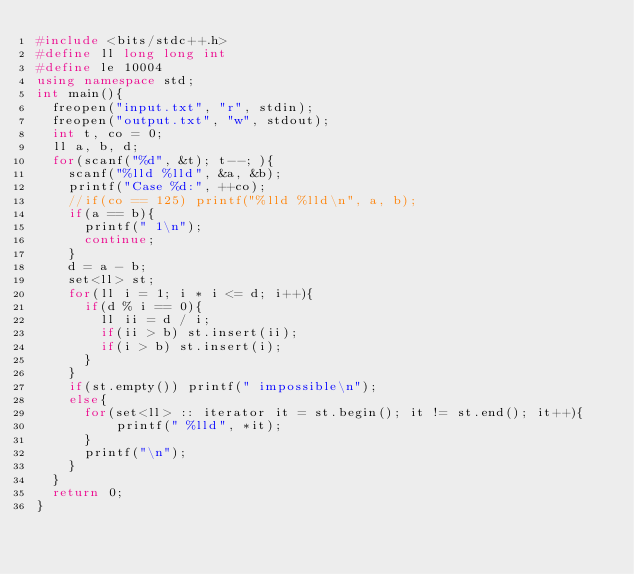Convert code to text. <code><loc_0><loc_0><loc_500><loc_500><_C++_>#include <bits/stdc++.h>
#define ll long long int
#define le 10004
using namespace std;
int main(){
  freopen("input.txt", "r", stdin);
  freopen("output.txt", "w", stdout);
  int t, co = 0;
  ll a, b, d;
  for(scanf("%d", &t); t--; ){
    scanf("%lld %lld", &a, &b);
    printf("Case %d:", ++co);
    //if(co == 125) printf("%lld %lld\n", a, b);
    if(a == b){
      printf(" 1\n");
      continue;
    }
    d = a - b;
    set<ll> st;
    for(ll i = 1; i * i <= d; i++){
      if(d % i == 0){
        ll ii = d / i;
        if(ii > b) st.insert(ii);
        if(i > b) st.insert(i);
      }
    }
    if(st.empty()) printf(" impossible\n");
    else{
      for(set<ll> :: iterator it = st.begin(); it != st.end(); it++){
          printf(" %lld", *it);
      }
      printf("\n");
    }
  }
  return 0;
}
</code> 